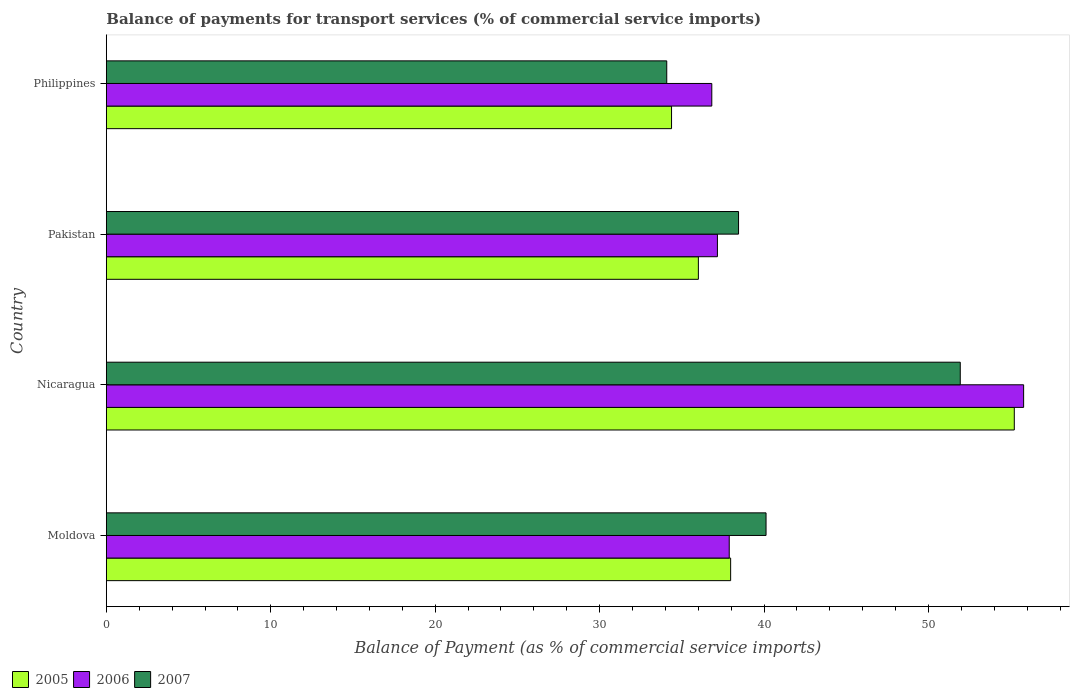How many different coloured bars are there?
Give a very brief answer. 3. How many groups of bars are there?
Ensure brevity in your answer.  4. Are the number of bars on each tick of the Y-axis equal?
Provide a short and direct response. Yes. How many bars are there on the 4th tick from the top?
Keep it short and to the point. 3. How many bars are there on the 4th tick from the bottom?
Your response must be concise. 3. In how many cases, is the number of bars for a given country not equal to the number of legend labels?
Give a very brief answer. 0. What is the balance of payments for transport services in 2006 in Moldova?
Keep it short and to the point. 37.88. Across all countries, what is the maximum balance of payments for transport services in 2007?
Your answer should be very brief. 51.93. Across all countries, what is the minimum balance of payments for transport services in 2006?
Offer a terse response. 36.82. In which country was the balance of payments for transport services in 2006 maximum?
Give a very brief answer. Nicaragua. What is the total balance of payments for transport services in 2005 in the graph?
Your answer should be compact. 163.56. What is the difference between the balance of payments for transport services in 2005 in Pakistan and that in Philippines?
Give a very brief answer. 1.63. What is the difference between the balance of payments for transport services in 2006 in Philippines and the balance of payments for transport services in 2005 in Pakistan?
Offer a very short reply. 0.82. What is the average balance of payments for transport services in 2007 per country?
Provide a short and direct response. 41.15. What is the difference between the balance of payments for transport services in 2007 and balance of payments for transport services in 2006 in Nicaragua?
Give a very brief answer. -3.85. What is the ratio of the balance of payments for transport services in 2007 in Moldova to that in Philippines?
Offer a very short reply. 1.18. Is the balance of payments for transport services in 2005 in Moldova less than that in Nicaragua?
Offer a terse response. Yes. What is the difference between the highest and the second highest balance of payments for transport services in 2007?
Keep it short and to the point. 11.81. What is the difference between the highest and the lowest balance of payments for transport services in 2005?
Your answer should be very brief. 20.84. What does the 2nd bar from the top in Nicaragua represents?
Make the answer very short. 2006. What does the 3rd bar from the bottom in Philippines represents?
Your answer should be very brief. 2007. Is it the case that in every country, the sum of the balance of payments for transport services in 2005 and balance of payments for transport services in 2007 is greater than the balance of payments for transport services in 2006?
Provide a short and direct response. Yes. How many bars are there?
Your response must be concise. 12. How many countries are there in the graph?
Make the answer very short. 4. What is the difference between two consecutive major ticks on the X-axis?
Make the answer very short. 10. Are the values on the major ticks of X-axis written in scientific E-notation?
Your answer should be very brief. No. How many legend labels are there?
Your answer should be compact. 3. How are the legend labels stacked?
Offer a very short reply. Horizontal. What is the title of the graph?
Keep it short and to the point. Balance of payments for transport services (% of commercial service imports). Does "1978" appear as one of the legend labels in the graph?
Your answer should be very brief. No. What is the label or title of the X-axis?
Provide a short and direct response. Balance of Payment (as % of commercial service imports). What is the label or title of the Y-axis?
Give a very brief answer. Country. What is the Balance of Payment (as % of commercial service imports) of 2005 in Moldova?
Give a very brief answer. 37.97. What is the Balance of Payment (as % of commercial service imports) of 2006 in Moldova?
Ensure brevity in your answer.  37.88. What is the Balance of Payment (as % of commercial service imports) of 2007 in Moldova?
Provide a succinct answer. 40.12. What is the Balance of Payment (as % of commercial service imports) in 2005 in Nicaragua?
Offer a terse response. 55.22. What is the Balance of Payment (as % of commercial service imports) in 2006 in Nicaragua?
Make the answer very short. 55.78. What is the Balance of Payment (as % of commercial service imports) of 2007 in Nicaragua?
Make the answer very short. 51.93. What is the Balance of Payment (as % of commercial service imports) in 2005 in Pakistan?
Provide a succinct answer. 36. What is the Balance of Payment (as % of commercial service imports) of 2006 in Pakistan?
Your response must be concise. 37.16. What is the Balance of Payment (as % of commercial service imports) in 2007 in Pakistan?
Offer a very short reply. 38.45. What is the Balance of Payment (as % of commercial service imports) in 2005 in Philippines?
Offer a terse response. 34.37. What is the Balance of Payment (as % of commercial service imports) of 2006 in Philippines?
Offer a very short reply. 36.82. What is the Balance of Payment (as % of commercial service imports) of 2007 in Philippines?
Your answer should be very brief. 34.08. Across all countries, what is the maximum Balance of Payment (as % of commercial service imports) in 2005?
Provide a short and direct response. 55.22. Across all countries, what is the maximum Balance of Payment (as % of commercial service imports) of 2006?
Offer a terse response. 55.78. Across all countries, what is the maximum Balance of Payment (as % of commercial service imports) of 2007?
Your answer should be very brief. 51.93. Across all countries, what is the minimum Balance of Payment (as % of commercial service imports) in 2005?
Provide a short and direct response. 34.37. Across all countries, what is the minimum Balance of Payment (as % of commercial service imports) in 2006?
Ensure brevity in your answer.  36.82. Across all countries, what is the minimum Balance of Payment (as % of commercial service imports) in 2007?
Make the answer very short. 34.08. What is the total Balance of Payment (as % of commercial service imports) of 2005 in the graph?
Your answer should be compact. 163.56. What is the total Balance of Payment (as % of commercial service imports) of 2006 in the graph?
Your answer should be compact. 167.65. What is the total Balance of Payment (as % of commercial service imports) in 2007 in the graph?
Keep it short and to the point. 164.58. What is the difference between the Balance of Payment (as % of commercial service imports) of 2005 in Moldova and that in Nicaragua?
Your answer should be compact. -17.25. What is the difference between the Balance of Payment (as % of commercial service imports) in 2006 in Moldova and that in Nicaragua?
Your answer should be very brief. -17.9. What is the difference between the Balance of Payment (as % of commercial service imports) in 2007 in Moldova and that in Nicaragua?
Ensure brevity in your answer.  -11.81. What is the difference between the Balance of Payment (as % of commercial service imports) in 2005 in Moldova and that in Pakistan?
Your answer should be very brief. 1.96. What is the difference between the Balance of Payment (as % of commercial service imports) of 2006 in Moldova and that in Pakistan?
Provide a succinct answer. 0.72. What is the difference between the Balance of Payment (as % of commercial service imports) of 2007 in Moldova and that in Pakistan?
Your answer should be very brief. 1.67. What is the difference between the Balance of Payment (as % of commercial service imports) of 2005 in Moldova and that in Philippines?
Ensure brevity in your answer.  3.59. What is the difference between the Balance of Payment (as % of commercial service imports) of 2006 in Moldova and that in Philippines?
Your answer should be compact. 1.06. What is the difference between the Balance of Payment (as % of commercial service imports) of 2007 in Moldova and that in Philippines?
Offer a terse response. 6.04. What is the difference between the Balance of Payment (as % of commercial service imports) of 2005 in Nicaragua and that in Pakistan?
Offer a very short reply. 19.21. What is the difference between the Balance of Payment (as % of commercial service imports) of 2006 in Nicaragua and that in Pakistan?
Your answer should be very brief. 18.62. What is the difference between the Balance of Payment (as % of commercial service imports) of 2007 in Nicaragua and that in Pakistan?
Offer a very short reply. 13.48. What is the difference between the Balance of Payment (as % of commercial service imports) in 2005 in Nicaragua and that in Philippines?
Your answer should be compact. 20.84. What is the difference between the Balance of Payment (as % of commercial service imports) in 2006 in Nicaragua and that in Philippines?
Your response must be concise. 18.96. What is the difference between the Balance of Payment (as % of commercial service imports) in 2007 in Nicaragua and that in Philippines?
Ensure brevity in your answer.  17.85. What is the difference between the Balance of Payment (as % of commercial service imports) in 2005 in Pakistan and that in Philippines?
Offer a very short reply. 1.63. What is the difference between the Balance of Payment (as % of commercial service imports) of 2006 in Pakistan and that in Philippines?
Keep it short and to the point. 0.34. What is the difference between the Balance of Payment (as % of commercial service imports) in 2007 in Pakistan and that in Philippines?
Offer a very short reply. 4.37. What is the difference between the Balance of Payment (as % of commercial service imports) in 2005 in Moldova and the Balance of Payment (as % of commercial service imports) in 2006 in Nicaragua?
Provide a short and direct response. -17.82. What is the difference between the Balance of Payment (as % of commercial service imports) of 2005 in Moldova and the Balance of Payment (as % of commercial service imports) of 2007 in Nicaragua?
Your answer should be very brief. -13.96. What is the difference between the Balance of Payment (as % of commercial service imports) in 2006 in Moldova and the Balance of Payment (as % of commercial service imports) in 2007 in Nicaragua?
Ensure brevity in your answer.  -14.05. What is the difference between the Balance of Payment (as % of commercial service imports) of 2005 in Moldova and the Balance of Payment (as % of commercial service imports) of 2006 in Pakistan?
Your response must be concise. 0.8. What is the difference between the Balance of Payment (as % of commercial service imports) of 2005 in Moldova and the Balance of Payment (as % of commercial service imports) of 2007 in Pakistan?
Ensure brevity in your answer.  -0.48. What is the difference between the Balance of Payment (as % of commercial service imports) of 2006 in Moldova and the Balance of Payment (as % of commercial service imports) of 2007 in Pakistan?
Offer a very short reply. -0.57. What is the difference between the Balance of Payment (as % of commercial service imports) of 2005 in Moldova and the Balance of Payment (as % of commercial service imports) of 2006 in Philippines?
Offer a terse response. 1.15. What is the difference between the Balance of Payment (as % of commercial service imports) of 2005 in Moldova and the Balance of Payment (as % of commercial service imports) of 2007 in Philippines?
Keep it short and to the point. 3.89. What is the difference between the Balance of Payment (as % of commercial service imports) in 2006 in Moldova and the Balance of Payment (as % of commercial service imports) in 2007 in Philippines?
Your answer should be compact. 3.8. What is the difference between the Balance of Payment (as % of commercial service imports) of 2005 in Nicaragua and the Balance of Payment (as % of commercial service imports) of 2006 in Pakistan?
Make the answer very short. 18.05. What is the difference between the Balance of Payment (as % of commercial service imports) in 2005 in Nicaragua and the Balance of Payment (as % of commercial service imports) in 2007 in Pakistan?
Your response must be concise. 16.77. What is the difference between the Balance of Payment (as % of commercial service imports) of 2006 in Nicaragua and the Balance of Payment (as % of commercial service imports) of 2007 in Pakistan?
Give a very brief answer. 17.34. What is the difference between the Balance of Payment (as % of commercial service imports) in 2005 in Nicaragua and the Balance of Payment (as % of commercial service imports) in 2006 in Philippines?
Your answer should be compact. 18.4. What is the difference between the Balance of Payment (as % of commercial service imports) in 2005 in Nicaragua and the Balance of Payment (as % of commercial service imports) in 2007 in Philippines?
Your answer should be compact. 21.14. What is the difference between the Balance of Payment (as % of commercial service imports) of 2006 in Nicaragua and the Balance of Payment (as % of commercial service imports) of 2007 in Philippines?
Your answer should be compact. 21.7. What is the difference between the Balance of Payment (as % of commercial service imports) in 2005 in Pakistan and the Balance of Payment (as % of commercial service imports) in 2006 in Philippines?
Your answer should be compact. -0.82. What is the difference between the Balance of Payment (as % of commercial service imports) in 2005 in Pakistan and the Balance of Payment (as % of commercial service imports) in 2007 in Philippines?
Your answer should be very brief. 1.92. What is the difference between the Balance of Payment (as % of commercial service imports) of 2006 in Pakistan and the Balance of Payment (as % of commercial service imports) of 2007 in Philippines?
Keep it short and to the point. 3.08. What is the average Balance of Payment (as % of commercial service imports) in 2005 per country?
Give a very brief answer. 40.89. What is the average Balance of Payment (as % of commercial service imports) in 2006 per country?
Ensure brevity in your answer.  41.91. What is the average Balance of Payment (as % of commercial service imports) in 2007 per country?
Ensure brevity in your answer.  41.15. What is the difference between the Balance of Payment (as % of commercial service imports) in 2005 and Balance of Payment (as % of commercial service imports) in 2006 in Moldova?
Your response must be concise. 0.09. What is the difference between the Balance of Payment (as % of commercial service imports) of 2005 and Balance of Payment (as % of commercial service imports) of 2007 in Moldova?
Your answer should be compact. -2.15. What is the difference between the Balance of Payment (as % of commercial service imports) in 2006 and Balance of Payment (as % of commercial service imports) in 2007 in Moldova?
Offer a terse response. -2.24. What is the difference between the Balance of Payment (as % of commercial service imports) of 2005 and Balance of Payment (as % of commercial service imports) of 2006 in Nicaragua?
Offer a very short reply. -0.57. What is the difference between the Balance of Payment (as % of commercial service imports) in 2005 and Balance of Payment (as % of commercial service imports) in 2007 in Nicaragua?
Your answer should be very brief. 3.29. What is the difference between the Balance of Payment (as % of commercial service imports) in 2006 and Balance of Payment (as % of commercial service imports) in 2007 in Nicaragua?
Offer a terse response. 3.85. What is the difference between the Balance of Payment (as % of commercial service imports) of 2005 and Balance of Payment (as % of commercial service imports) of 2006 in Pakistan?
Keep it short and to the point. -1.16. What is the difference between the Balance of Payment (as % of commercial service imports) of 2005 and Balance of Payment (as % of commercial service imports) of 2007 in Pakistan?
Keep it short and to the point. -2.44. What is the difference between the Balance of Payment (as % of commercial service imports) in 2006 and Balance of Payment (as % of commercial service imports) in 2007 in Pakistan?
Provide a short and direct response. -1.28. What is the difference between the Balance of Payment (as % of commercial service imports) of 2005 and Balance of Payment (as % of commercial service imports) of 2006 in Philippines?
Give a very brief answer. -2.45. What is the difference between the Balance of Payment (as % of commercial service imports) of 2005 and Balance of Payment (as % of commercial service imports) of 2007 in Philippines?
Provide a short and direct response. 0.29. What is the difference between the Balance of Payment (as % of commercial service imports) of 2006 and Balance of Payment (as % of commercial service imports) of 2007 in Philippines?
Provide a short and direct response. 2.74. What is the ratio of the Balance of Payment (as % of commercial service imports) of 2005 in Moldova to that in Nicaragua?
Make the answer very short. 0.69. What is the ratio of the Balance of Payment (as % of commercial service imports) of 2006 in Moldova to that in Nicaragua?
Provide a succinct answer. 0.68. What is the ratio of the Balance of Payment (as % of commercial service imports) of 2007 in Moldova to that in Nicaragua?
Your answer should be very brief. 0.77. What is the ratio of the Balance of Payment (as % of commercial service imports) in 2005 in Moldova to that in Pakistan?
Offer a terse response. 1.05. What is the ratio of the Balance of Payment (as % of commercial service imports) of 2006 in Moldova to that in Pakistan?
Ensure brevity in your answer.  1.02. What is the ratio of the Balance of Payment (as % of commercial service imports) in 2007 in Moldova to that in Pakistan?
Keep it short and to the point. 1.04. What is the ratio of the Balance of Payment (as % of commercial service imports) in 2005 in Moldova to that in Philippines?
Make the answer very short. 1.1. What is the ratio of the Balance of Payment (as % of commercial service imports) in 2006 in Moldova to that in Philippines?
Your answer should be very brief. 1.03. What is the ratio of the Balance of Payment (as % of commercial service imports) of 2007 in Moldova to that in Philippines?
Ensure brevity in your answer.  1.18. What is the ratio of the Balance of Payment (as % of commercial service imports) of 2005 in Nicaragua to that in Pakistan?
Give a very brief answer. 1.53. What is the ratio of the Balance of Payment (as % of commercial service imports) in 2006 in Nicaragua to that in Pakistan?
Make the answer very short. 1.5. What is the ratio of the Balance of Payment (as % of commercial service imports) of 2007 in Nicaragua to that in Pakistan?
Provide a short and direct response. 1.35. What is the ratio of the Balance of Payment (as % of commercial service imports) of 2005 in Nicaragua to that in Philippines?
Keep it short and to the point. 1.61. What is the ratio of the Balance of Payment (as % of commercial service imports) in 2006 in Nicaragua to that in Philippines?
Offer a very short reply. 1.51. What is the ratio of the Balance of Payment (as % of commercial service imports) in 2007 in Nicaragua to that in Philippines?
Make the answer very short. 1.52. What is the ratio of the Balance of Payment (as % of commercial service imports) of 2005 in Pakistan to that in Philippines?
Ensure brevity in your answer.  1.05. What is the ratio of the Balance of Payment (as % of commercial service imports) of 2006 in Pakistan to that in Philippines?
Make the answer very short. 1.01. What is the ratio of the Balance of Payment (as % of commercial service imports) in 2007 in Pakistan to that in Philippines?
Make the answer very short. 1.13. What is the difference between the highest and the second highest Balance of Payment (as % of commercial service imports) of 2005?
Your answer should be very brief. 17.25. What is the difference between the highest and the second highest Balance of Payment (as % of commercial service imports) in 2006?
Offer a terse response. 17.9. What is the difference between the highest and the second highest Balance of Payment (as % of commercial service imports) of 2007?
Keep it short and to the point. 11.81. What is the difference between the highest and the lowest Balance of Payment (as % of commercial service imports) in 2005?
Provide a short and direct response. 20.84. What is the difference between the highest and the lowest Balance of Payment (as % of commercial service imports) in 2006?
Provide a succinct answer. 18.96. What is the difference between the highest and the lowest Balance of Payment (as % of commercial service imports) in 2007?
Provide a short and direct response. 17.85. 